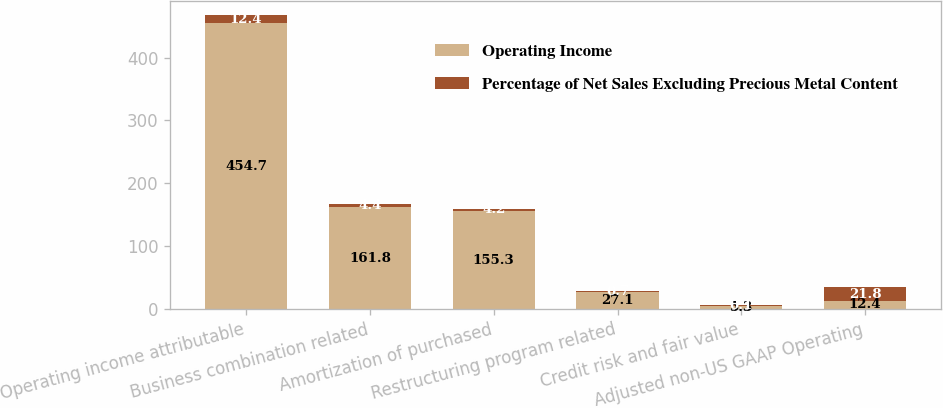Convert chart to OTSL. <chart><loc_0><loc_0><loc_500><loc_500><stacked_bar_chart><ecel><fcel>Operating income attributable<fcel>Business combination related<fcel>Amortization of purchased<fcel>Restructuring program related<fcel>Credit risk and fair value<fcel>Adjusted non-US GAAP Operating<nl><fcel>Operating Income<fcel>454.7<fcel>161.8<fcel>155.3<fcel>27.1<fcel>5.3<fcel>12.4<nl><fcel>Percentage of Net Sales Excluding Precious Metal Content<fcel>12.4<fcel>4.4<fcel>4.2<fcel>0.7<fcel>0.1<fcel>21.8<nl></chart> 